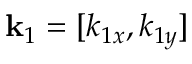Convert formula to latex. <formula><loc_0><loc_0><loc_500><loc_500>k _ { 1 } = [ k _ { 1 x } , k _ { 1 y } ]</formula> 